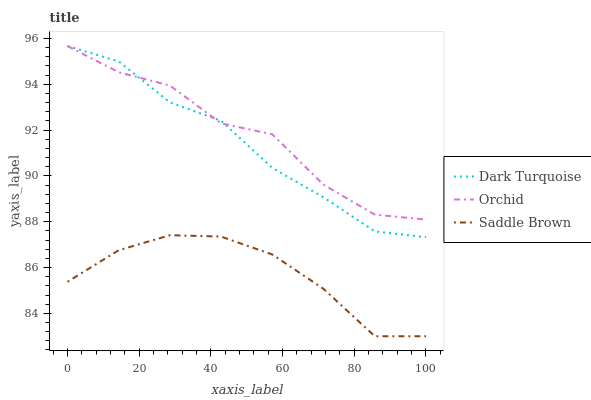Does Saddle Brown have the minimum area under the curve?
Answer yes or no. Yes. Does Orchid have the maximum area under the curve?
Answer yes or no. Yes. Does Orchid have the minimum area under the curve?
Answer yes or no. No. Does Saddle Brown have the maximum area under the curve?
Answer yes or no. No. Is Saddle Brown the smoothest?
Answer yes or no. Yes. Is Orchid the roughest?
Answer yes or no. Yes. Is Orchid the smoothest?
Answer yes or no. No. Is Saddle Brown the roughest?
Answer yes or no. No. Does Saddle Brown have the lowest value?
Answer yes or no. Yes. Does Orchid have the lowest value?
Answer yes or no. No. Does Dark Turquoise have the highest value?
Answer yes or no. Yes. Does Orchid have the highest value?
Answer yes or no. No. Is Saddle Brown less than Orchid?
Answer yes or no. Yes. Is Dark Turquoise greater than Saddle Brown?
Answer yes or no. Yes. Does Orchid intersect Dark Turquoise?
Answer yes or no. Yes. Is Orchid less than Dark Turquoise?
Answer yes or no. No. Is Orchid greater than Dark Turquoise?
Answer yes or no. No. Does Saddle Brown intersect Orchid?
Answer yes or no. No. 